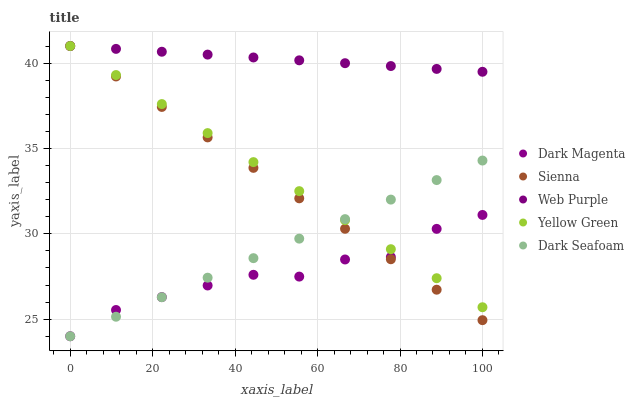Does Dark Magenta have the minimum area under the curve?
Answer yes or no. Yes. Does Web Purple have the maximum area under the curve?
Answer yes or no. Yes. Does Web Purple have the minimum area under the curve?
Answer yes or no. No. Does Dark Magenta have the maximum area under the curve?
Answer yes or no. No. Is Sienna the smoothest?
Answer yes or no. Yes. Is Dark Magenta the roughest?
Answer yes or no. Yes. Is Web Purple the smoothest?
Answer yes or no. No. Is Web Purple the roughest?
Answer yes or no. No. Does Dark Magenta have the lowest value?
Answer yes or no. Yes. Does Web Purple have the lowest value?
Answer yes or no. No. Does Yellow Green have the highest value?
Answer yes or no. Yes. Does Dark Magenta have the highest value?
Answer yes or no. No. Is Dark Seafoam less than Web Purple?
Answer yes or no. Yes. Is Web Purple greater than Dark Magenta?
Answer yes or no. Yes. Does Yellow Green intersect Web Purple?
Answer yes or no. Yes. Is Yellow Green less than Web Purple?
Answer yes or no. No. Is Yellow Green greater than Web Purple?
Answer yes or no. No. Does Dark Seafoam intersect Web Purple?
Answer yes or no. No. 